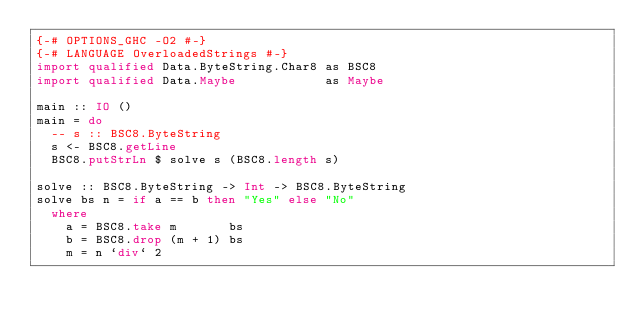<code> <loc_0><loc_0><loc_500><loc_500><_Haskell_>{-# OPTIONS_GHC -O2 #-}
{-# LANGUAGE OverloadedStrings #-}
import qualified Data.ByteString.Char8 as BSC8
import qualified Data.Maybe            as Maybe

main :: IO ()
main = do
  -- s :: BSC8.ByteString
  s <- BSC8.getLine
  BSC8.putStrLn $ solve s (BSC8.length s)

solve :: BSC8.ByteString -> Int -> BSC8.ByteString
solve bs n = if a == b then "Yes" else "No"
  where
    a = BSC8.take m       bs
    b = BSC8.drop (m + 1) bs
    m = n `div` 2</code> 